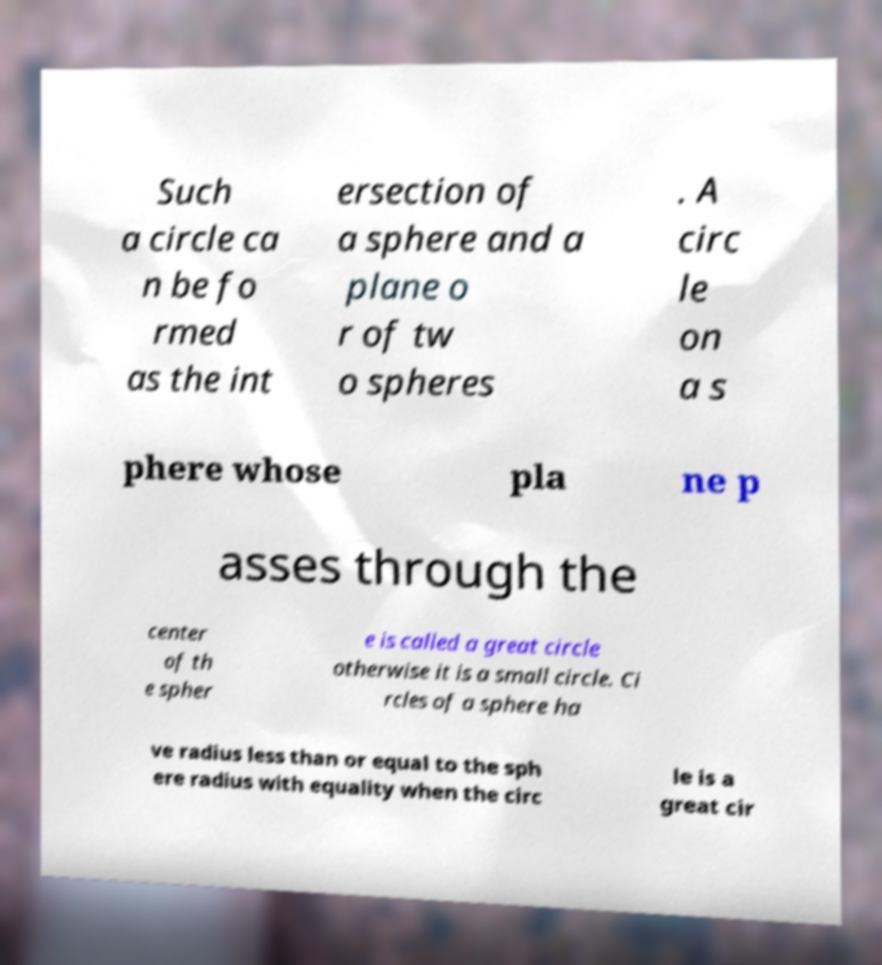Can you read and provide the text displayed in the image?This photo seems to have some interesting text. Can you extract and type it out for me? Such a circle ca n be fo rmed as the int ersection of a sphere and a plane o r of tw o spheres . A circ le on a s phere whose pla ne p asses through the center of th e spher e is called a great circle otherwise it is a small circle. Ci rcles of a sphere ha ve radius less than or equal to the sph ere radius with equality when the circ le is a great cir 